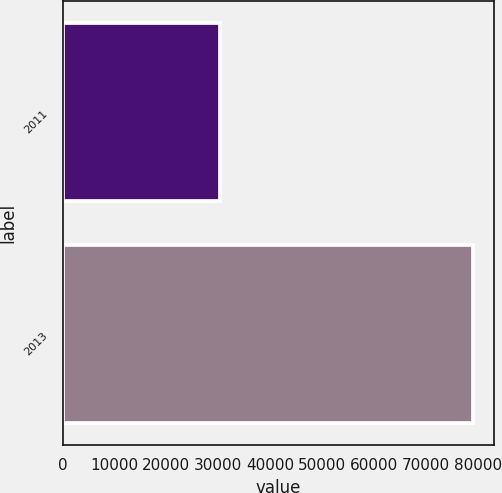Convert chart. <chart><loc_0><loc_0><loc_500><loc_500><bar_chart><fcel>2011<fcel>2013<nl><fcel>30243<fcel>79123<nl></chart> 